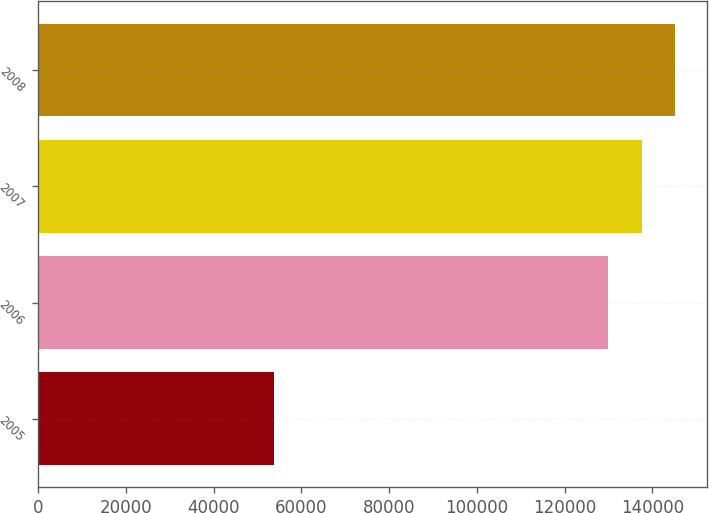Convert chart to OTSL. <chart><loc_0><loc_0><loc_500><loc_500><bar_chart><fcel>2005<fcel>2006<fcel>2007<fcel>2008<nl><fcel>53699<fcel>130000<fcel>137630<fcel>145260<nl></chart> 